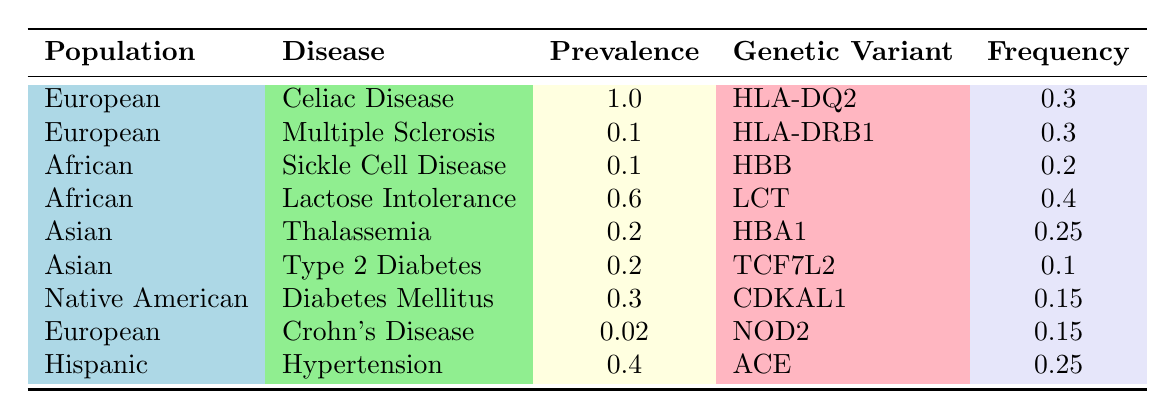What is the prevalence of Celiac Disease in the European population? The table indicates that the prevalence of Celiac Disease in the European population is listed directly beside it. Looking at the table, the value is 1.0.
Answer: 1.0 What is the genetic variant associated with Lactose Intolerance in the African population? By examining the table, we find Lactose Intolerance under the African population and see that it is associated with the genetic variant LCT.
Answer: LCT Which population has the highest frequency of a genetic variant? To determine which population has the highest frequency of a genetic variant, we can scan through the Frequency column. The highest frequency is 0.4, associated with Lactose Intolerance in the African population.
Answer: African population (Lactose Intolerance) Is the prevalence of Multiple Sclerosis higher than that of Crohn's Disease in the European population? We look at the table to find the prevalence values: Multiple Sclerosis is 0.1 and Crohn's Disease is 0.02. Since 0.1 is greater than 0.02, the statement is true.
Answer: Yes What is the average prevalence of diseases listed for the Asian population? For the Asian population, the relevant prevalence values are 0.2 (Thalassemia) and 0.2 (Type 2 Diabetes). Adding these together gives 0.2 + 0.2 = 0.4, and dividing by the number of diseases (2) gives 0.4 / 2 = 0.2.
Answer: 0.2 Do Europeans have a genetic variant frequency associated with Crohn's Disease? The table shows that Crohn's Disease is indeed listed under the European population and has a genetic variant (NOD2) with a frequency of 0.15. Thus, the statement is true.
Answer: Yes What is the difference in prevalence between Lactose Intolerance and Sickle Cell Disease? The prevalence of Lactose Intolerance is 0.6, while Sickle Cell Disease is 0.1. The difference is 0.6 - 0.1 = 0.5.
Answer: 0.5 Which disease has the lowest prevalence in the provided data? By scanning the Prevalence column, we find that Crohn's Disease has the lowest prevalence listed at 0.02, making it the disease with the least prevalence.
Answer: Crohn's Disease In the Hispanic population, what is the frequency of the genetic variant associated with Hypertension? The table shows that Hypertension is associated with the genetic variant ACE, and the frequency next to it is 0.25.
Answer: 0.25 Which population suffers from Diabetes Mellitus, and what is its prevalence? Looking at the table, Diabetes Mellitus is associated with the Native American population, and the corresponding prevalence is 0.3.
Answer: Native American, 0.3 